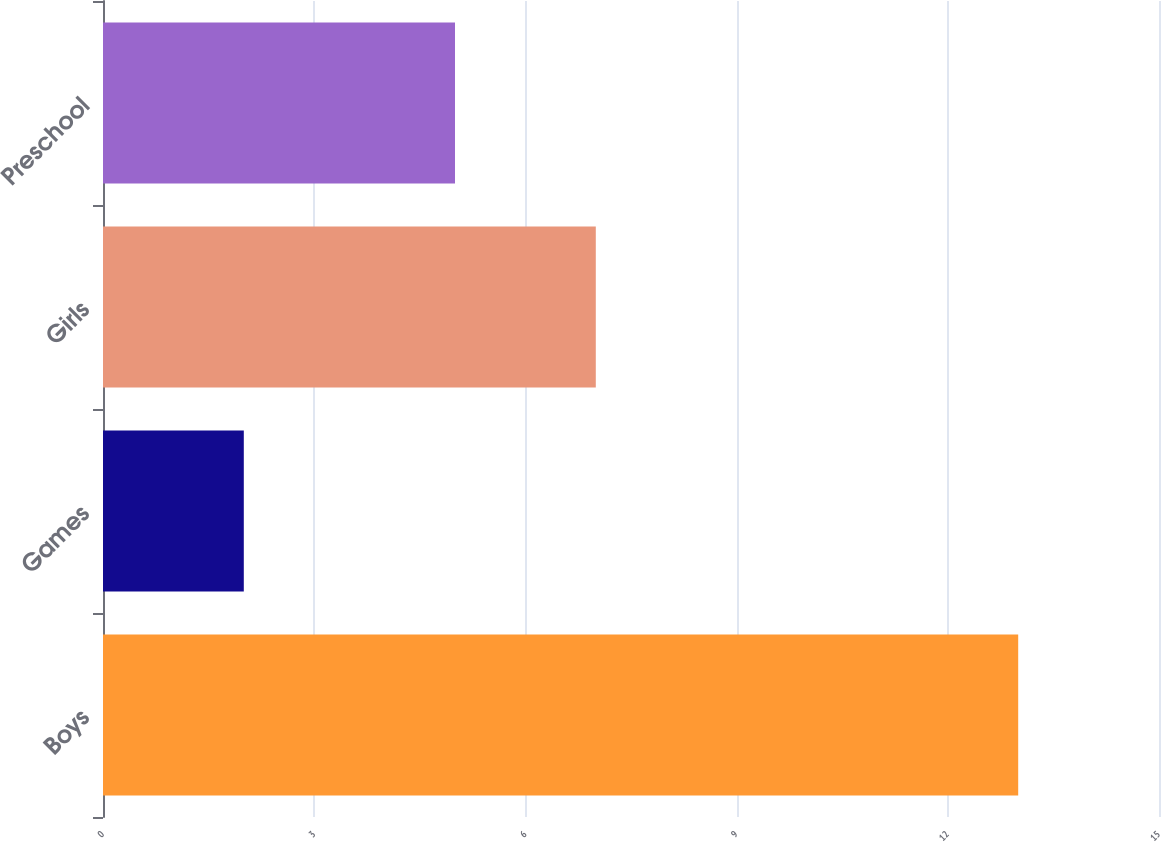Convert chart. <chart><loc_0><loc_0><loc_500><loc_500><bar_chart><fcel>Boys<fcel>Games<fcel>Girls<fcel>Preschool<nl><fcel>13<fcel>2<fcel>7<fcel>5<nl></chart> 